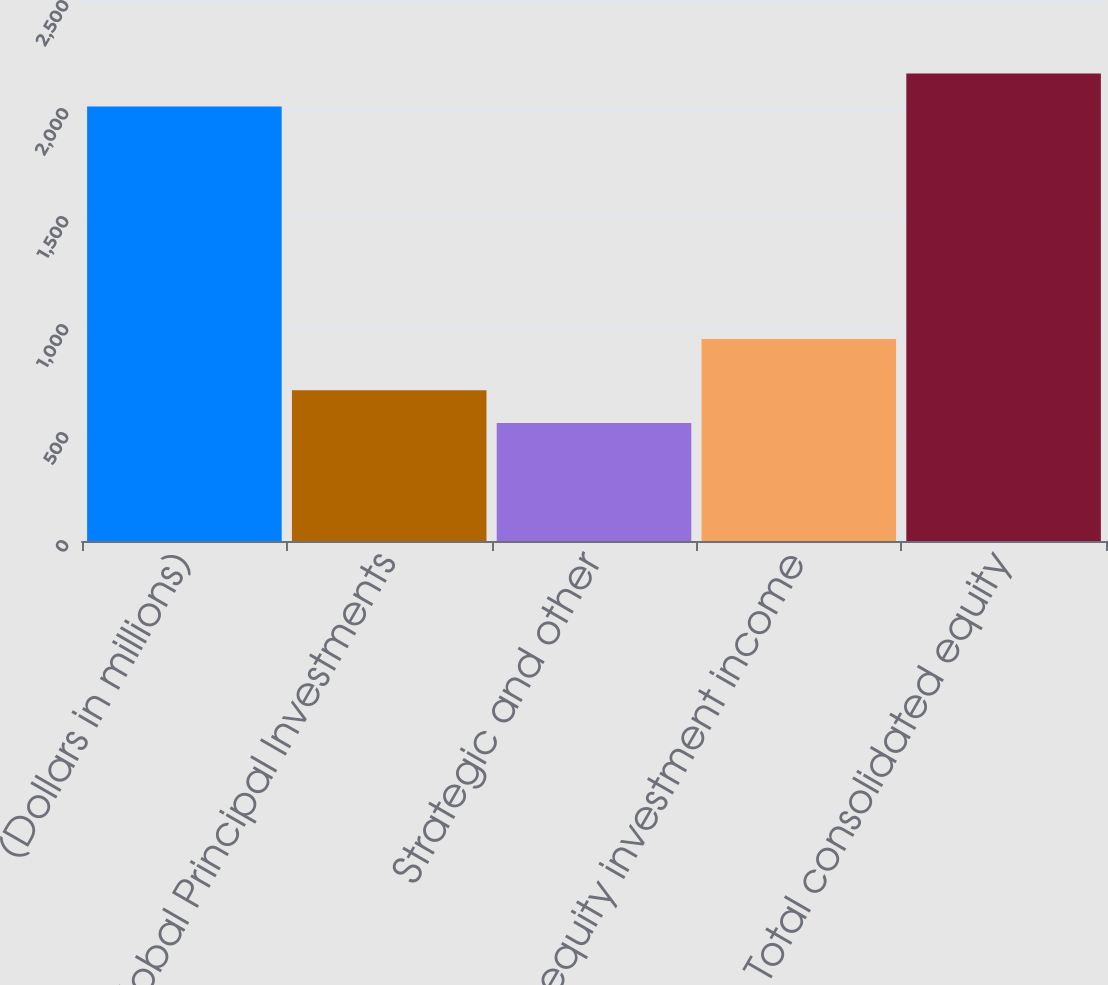<chart> <loc_0><loc_0><loc_500><loc_500><bar_chart><fcel>(Dollars in millions)<fcel>Global Principal Investments<fcel>Strategic and other<fcel>Total equity investment income<fcel>Total consolidated equity<nl><fcel>2012<fcel>698.4<fcel>546<fcel>935<fcel>2164.4<nl></chart> 